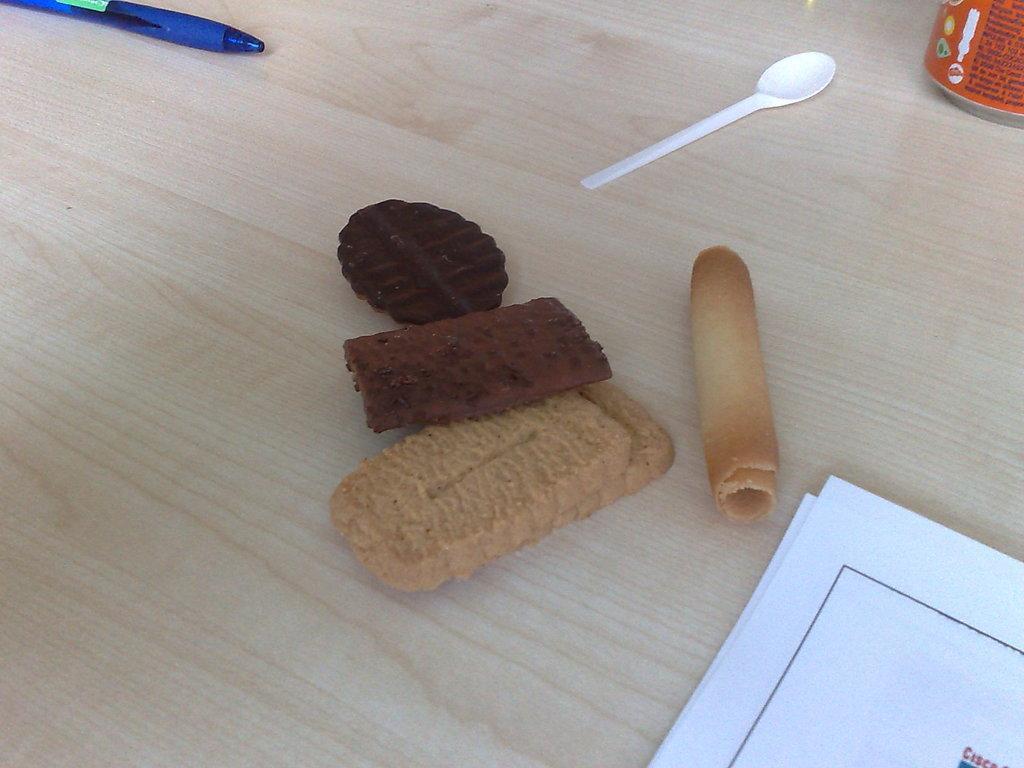Can you describe this image briefly? In this picture there are some biscuits on the table, in the right corner there are some papers and a tin and a spoon on the table and a pen in the left corner of the picture. 